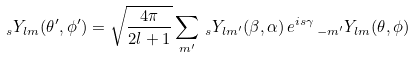<formula> <loc_0><loc_0><loc_500><loc_500>\, _ { s } Y _ { l m } ( \theta ^ { \prime } , \phi ^ { \prime } ) = \sqrt { \frac { 4 \pi } { 2 l + 1 } } \sum _ { m ^ { \prime } } \, _ { s } Y _ { l m ^ { \prime } } ( \beta , \alpha ) \, e ^ { i s \gamma } \, _ { - m ^ { \prime } } Y _ { l m } ( \theta , \phi )</formula> 